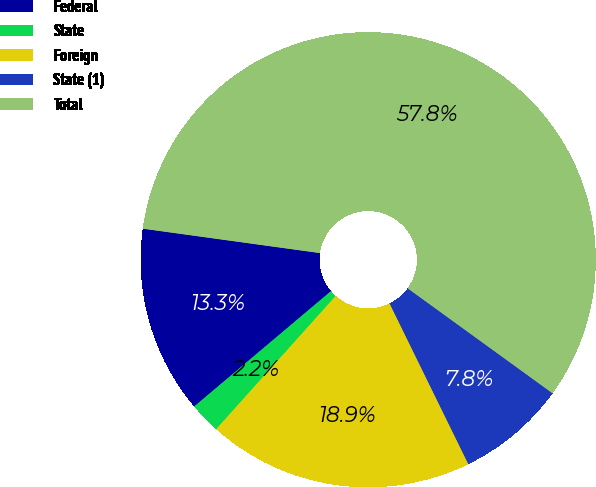Convert chart to OTSL. <chart><loc_0><loc_0><loc_500><loc_500><pie_chart><fcel>Federal<fcel>State<fcel>Foreign<fcel>State (1)<fcel>Total<nl><fcel>13.33%<fcel>2.21%<fcel>18.89%<fcel>7.77%<fcel>57.8%<nl></chart> 